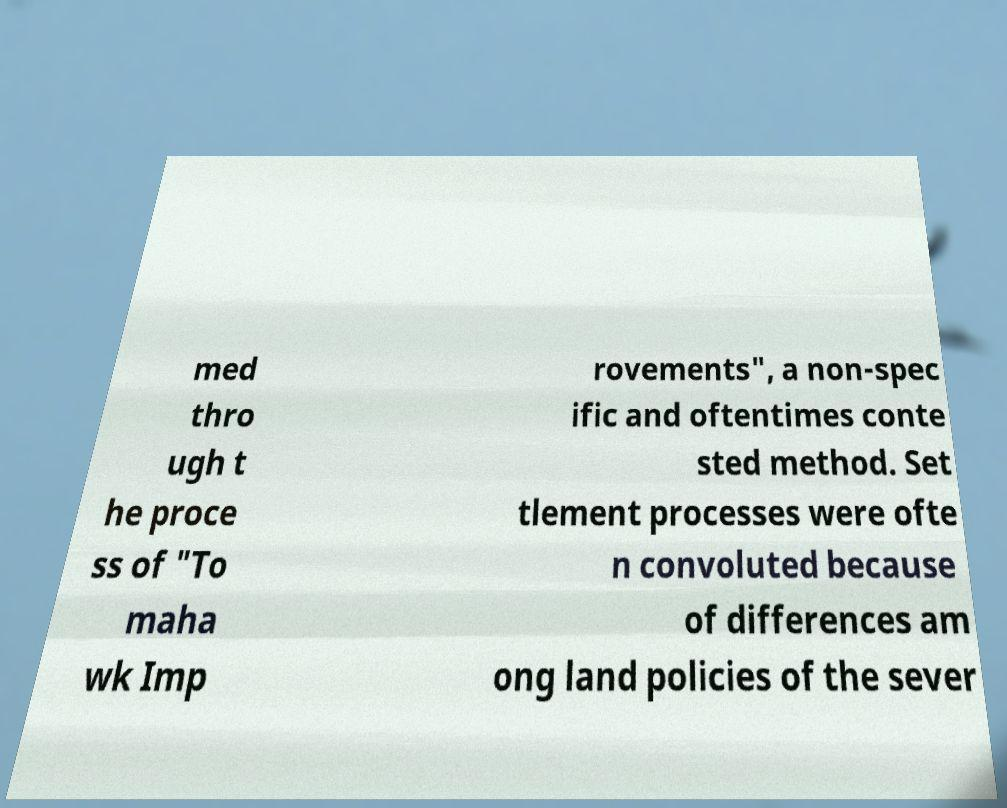Please read and relay the text visible in this image. What does it say? med thro ugh t he proce ss of "To maha wk Imp rovements", a non-spec ific and oftentimes conte sted method. Set tlement processes were ofte n convoluted because of differences am ong land policies of the sever 